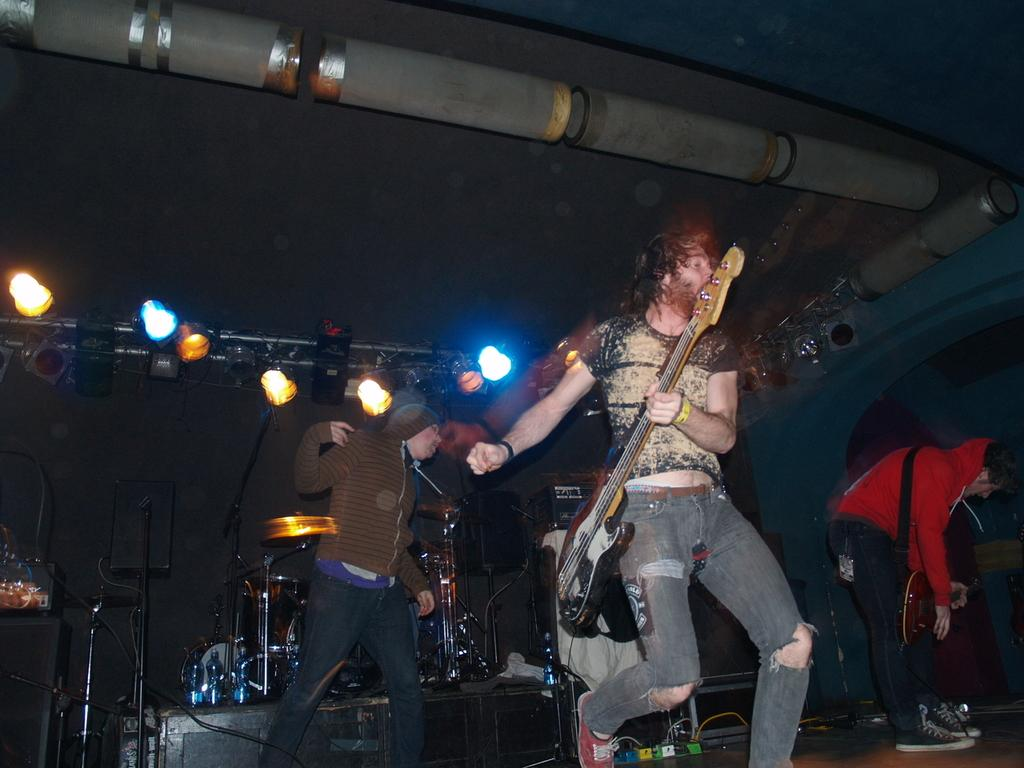What objects in the image emit light? There are lights in the image. How many people are present in the image? There are three people in the image. What is one of the people doing in the image? One of the people is holding a guitar. What other musical instrument can be seen in the image? There are musical drums visible in the image. What type of scent can be detected in the image? There is no mention of a scent in the image, so it cannot be determined from the image. 